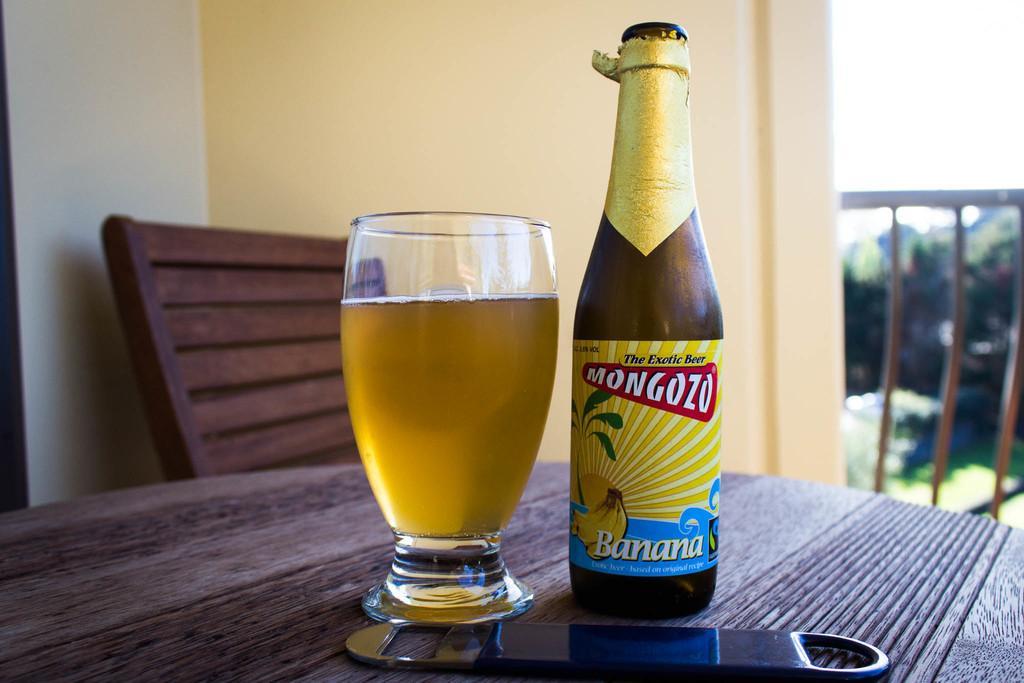Could you give a brief overview of what you see in this image? In this picture we can see a table and on the table there is a glass with some liquid, a bottle with a label and an opener. Behind the glass there is a chair, wall and the iron grilles. Behind the grilles there is the blurred background. 